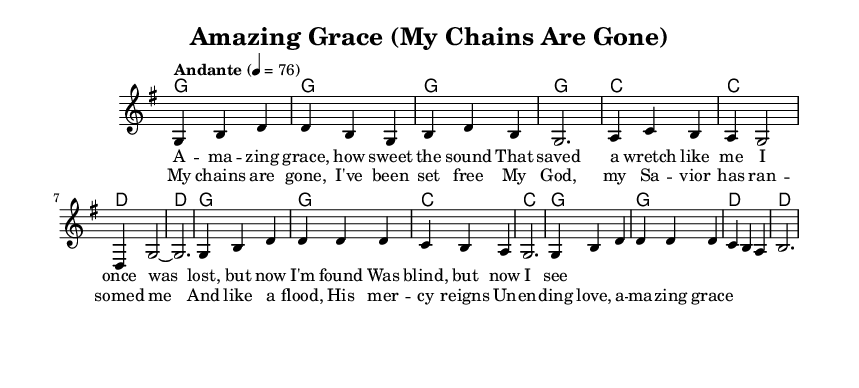What is the key signature of this music? The key signature is G major, which has one sharp (F#). This can be observed at the beginning of the staff, where the sharp is indicated.
Answer: G major What is the time signature of this piece? The time signature shown at the beginning is 3/4, which means there are three beats in each measure, and the quarter note gets one beat. This is indicated by the 3/4 marking at the start of the score.
Answer: 3/4 What is the tempo marking for the music? The tempo marking indicates "Andante," which means a moderately slow tempo. The metronome marking of 76 beats per minute provides a precise indication of the speed. Both these details are included at the beginning of the score.
Answer: Andante How many measures are in the verse? The verse consists of eight measures, which can be determined by counting each measure's bar line in the section where the verse lyrics are set.
Answer: Eight What is the main theme expressed in the lyrics of the chorus? The chorus conveys themes of freedom and grace, referring to being set free and experiencing mercy. This theme can be evaluated by reading the lyrics that emphasize redemption and unwavering love.
Answer: Freedom What is the first chord in the verse? The first chord in the verse is G major, which is indicated by the chord symbol at the start of the first measure.
Answer: G major What musical form does this piece follow? The piece features a verse and chorus structure, which can be noticed from the distinct separation of the lyrical content and musical sections. The initial lyrics represent the verse, followed by a separate part for the chorus.
Answer: Verse-Chorus 